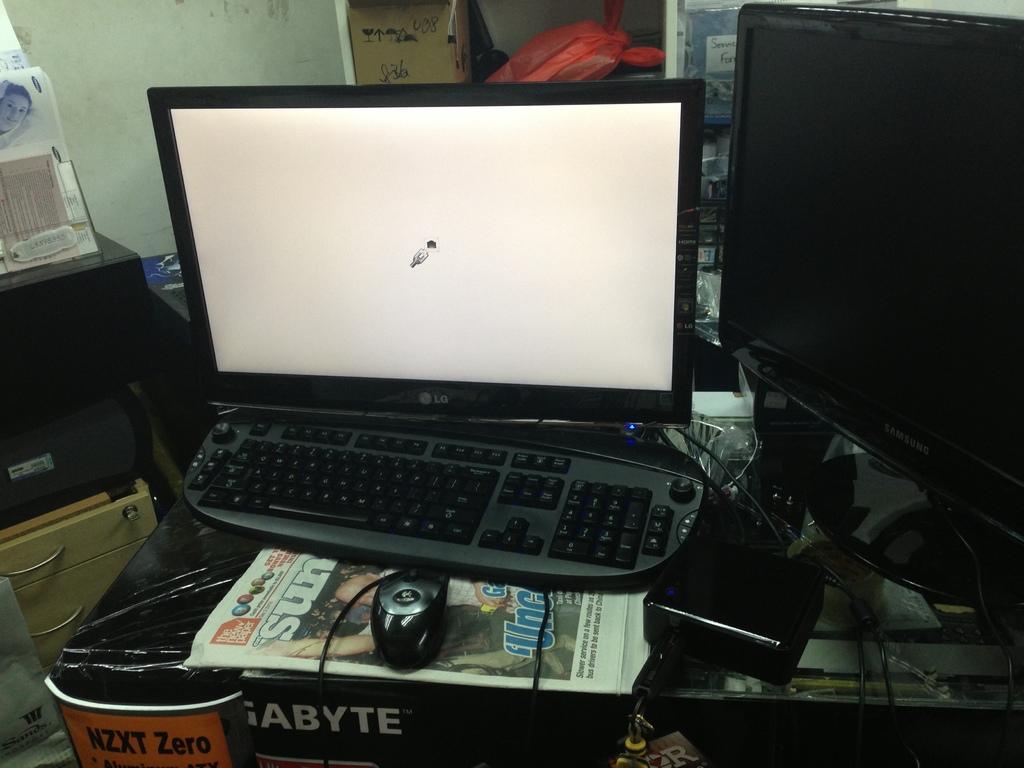What does the orange sign say?
Give a very brief answer. Nzxt zero. What brand is the monitor?
Keep it short and to the point. Lg. 